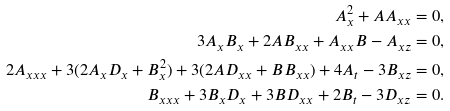Convert formula to latex. <formula><loc_0><loc_0><loc_500><loc_500>A _ { x } ^ { 2 } + A A _ { x x } = 0 , \\ 3 A _ { x } B _ { x } + 2 A B _ { x x } + A _ { x x } B - A _ { x z } = 0 , \\ 2 A _ { x x x } + 3 ( 2 A _ { x } D _ { x } + B _ { x } ^ { 2 } ) + 3 ( 2 A D _ { x x } + B B _ { x x } ) + 4 A _ { t } - 3 B _ { x z } = 0 , \\ B _ { x x x } + 3 B _ { x } D _ { x } + 3 B D _ { x x } + 2 B _ { t } - 3 D _ { x z } = 0 .</formula> 